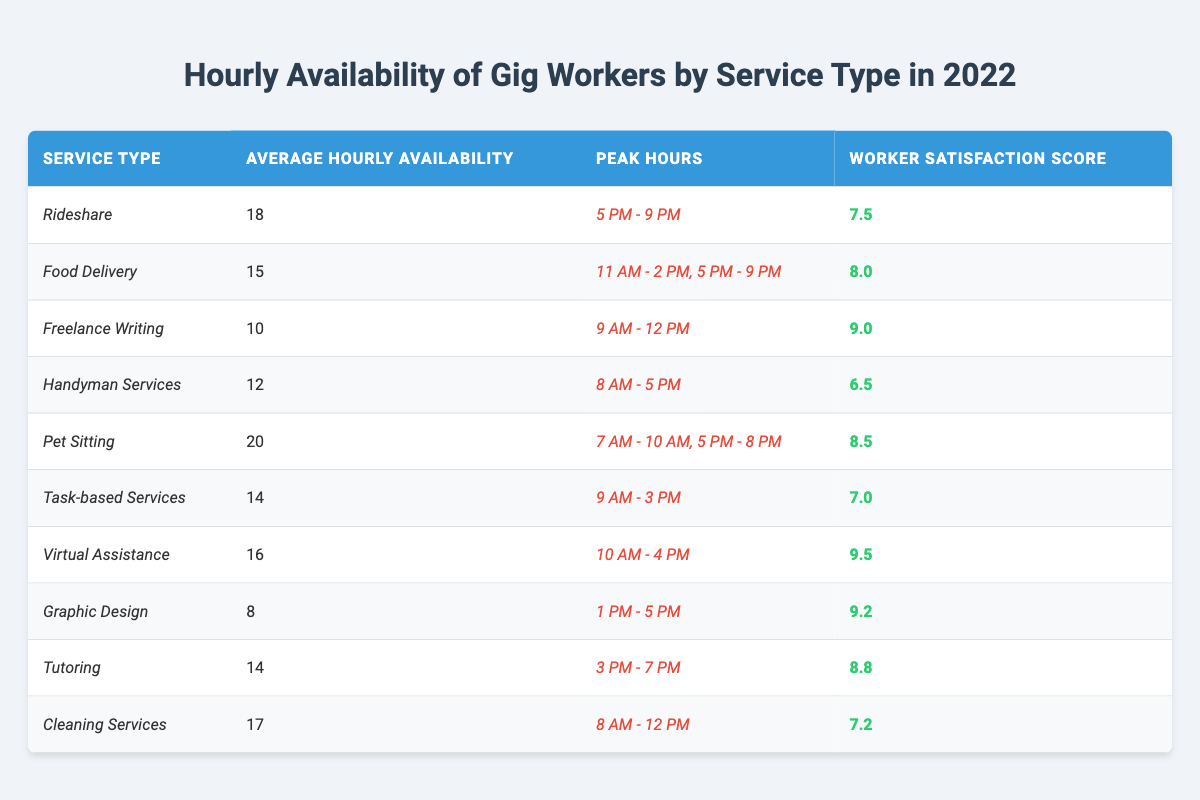What is the average hourly availability for Food Delivery gig workers? The table shows that the average hourly availability for Food Delivery is listed under the "Average Hourly Availability" column, where it is noted as 15 hours.
Answer: 15 Which service type has the highest worker satisfaction score? By examining the "Worker Satisfaction Score" column, the highest score is 9.5 for Virtual Assistance, which can be compared to the other scores to confirm it's the highest.
Answer: Virtual Assistance How many gig services have an average hourly availability of 14 hours? The table lists Task-based Services and Tutoring both with an average hourly availability of 14 hours. Counting these, there are 2 service types with that availability.
Answer: 2 What is the peak hour range for Rideshare services? The peak hours for Rideshare are specified in the "Peak Hours" column as 5 PM - 9 PM. This value can be directly referred from the table.
Answer: 5 PM - 9 PM What is the average hourly availability of Pet Sitting compared to Freelance Writing? The average hourly availability for Pet Sitting is 20 hours, while for Freelance Writing it is 10 hours. The difference is calculated as 20 - 10 = 10 hours, indicating that Pet Sitting has 10 more hours of availability.
Answer: 10 hours Is the worker satisfaction score for Handyman Services greater than that for Cleaning Services? The scores are 6.5 for Handyman Services and 7.2 for Cleaning Services. By comparing these values, we find that 6.5 is not greater than 7.2, confirming the statement is false.
Answer: No How does the average hourly availability of Virtual Assistance compare to that of Graphic Design? The average hourly availability for Virtual Assistance is 16 hours, while Graphic Design has an availability of 8 hours. The comparison shows that Virtual Assistance has 8 more hours of availability than Graphic Design.
Answer: 8 more hours Which service type has the longest peak hours based on the provided data? The peak hours for Food Delivery span across two periods: 11 AM - 2 PM and 5 PM - 9 PM. Calculating the total range for both, it has the most extended listed peak hours compared to others.
Answer: Food Delivery What is the total average hourly availability for all the services listed? Summing all average hourly availabilities: 18 + 15 + 10 + 12 + 20 + 14 + 16 + 8 + 14 + 17 =  144. This total is then divided by 10 (the number of services) to find the average: 144 / 10 = 14.4 hours.
Answer: 14.4 hours If a worker is available during all peak hours for each type, how many total hours can they work for Pet Sitting? The peak hours for Pet Sitting are illustrated as 7 AM - 10 AM (3 hours) and 5 PM - 8 PM (3 hours), totaling 3 + 3 = 6 hours during peak availability.
Answer: 6 hours 